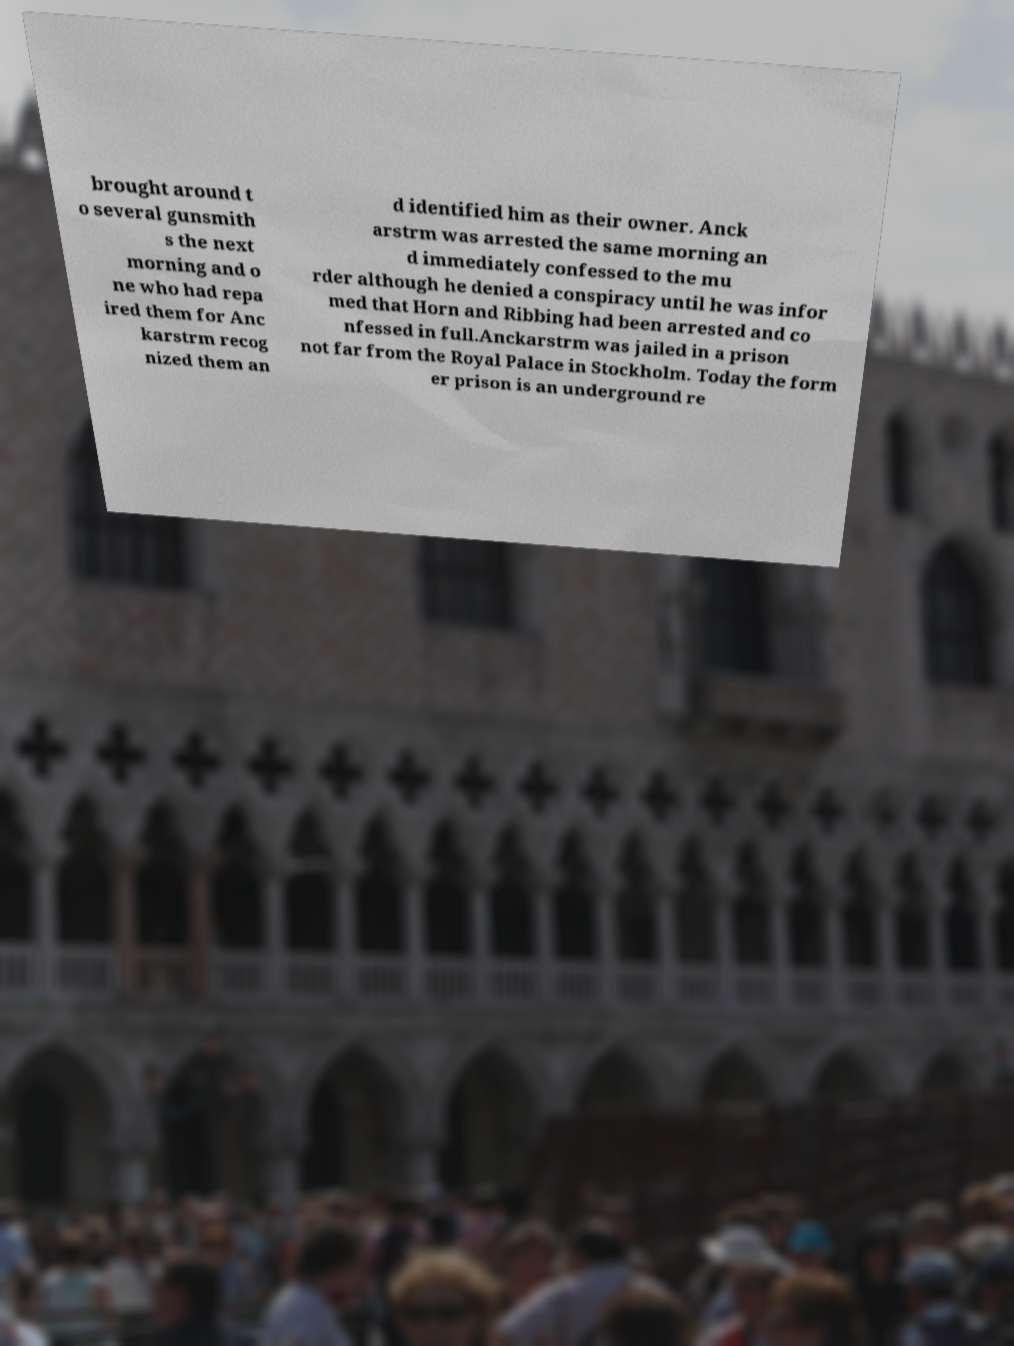Can you read and provide the text displayed in the image?This photo seems to have some interesting text. Can you extract and type it out for me? brought around t o several gunsmith s the next morning and o ne who had repa ired them for Anc karstrm recog nized them an d identified him as their owner. Anck arstrm was arrested the same morning an d immediately confessed to the mu rder although he denied a conspiracy until he was infor med that Horn and Ribbing had been arrested and co nfessed in full.Anckarstrm was jailed in a prison not far from the Royal Palace in Stockholm. Today the form er prison is an underground re 